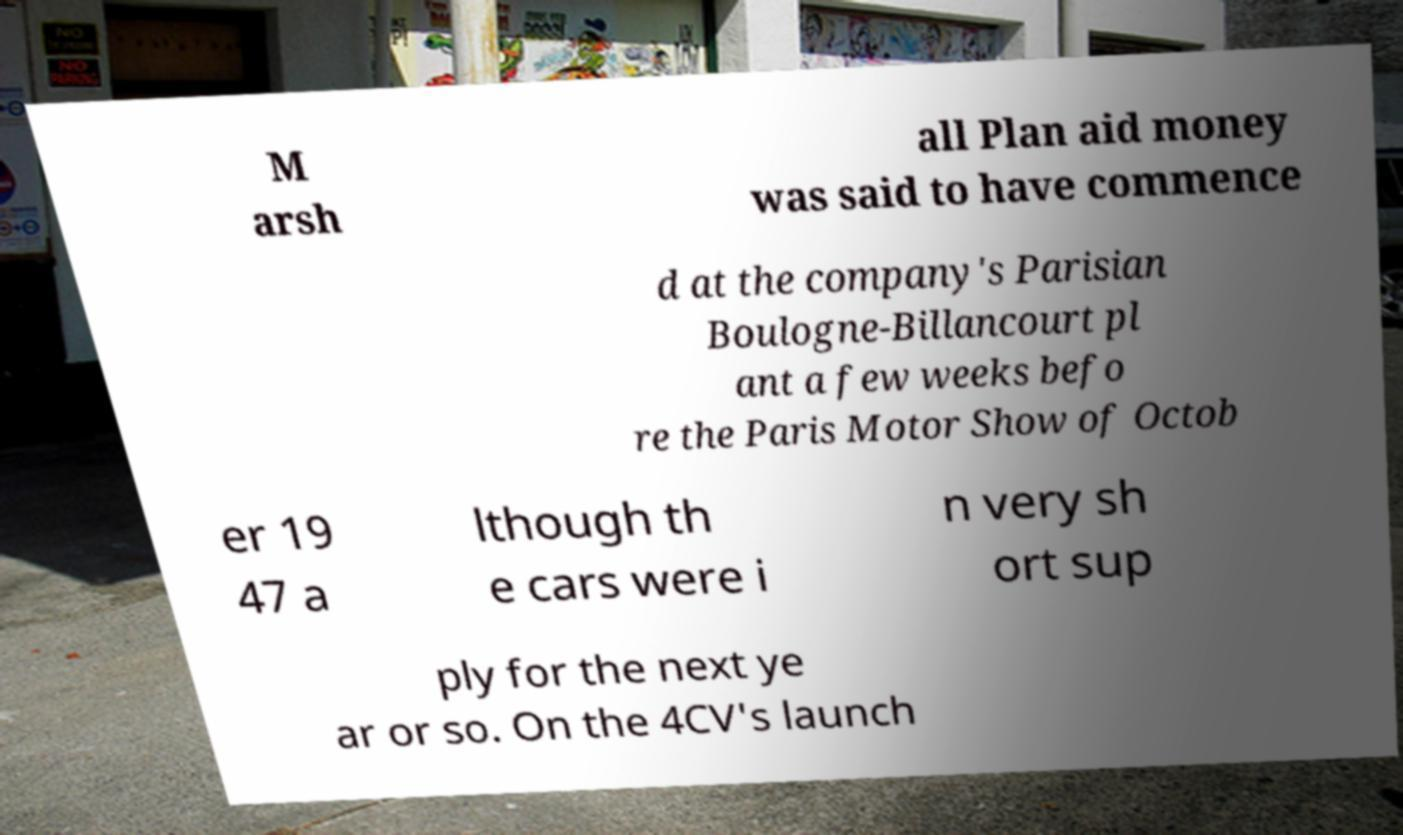Could you assist in decoding the text presented in this image and type it out clearly? M arsh all Plan aid money was said to have commence d at the company's Parisian Boulogne-Billancourt pl ant a few weeks befo re the Paris Motor Show of Octob er 19 47 a lthough th e cars were i n very sh ort sup ply for the next ye ar or so. On the 4CV's launch 